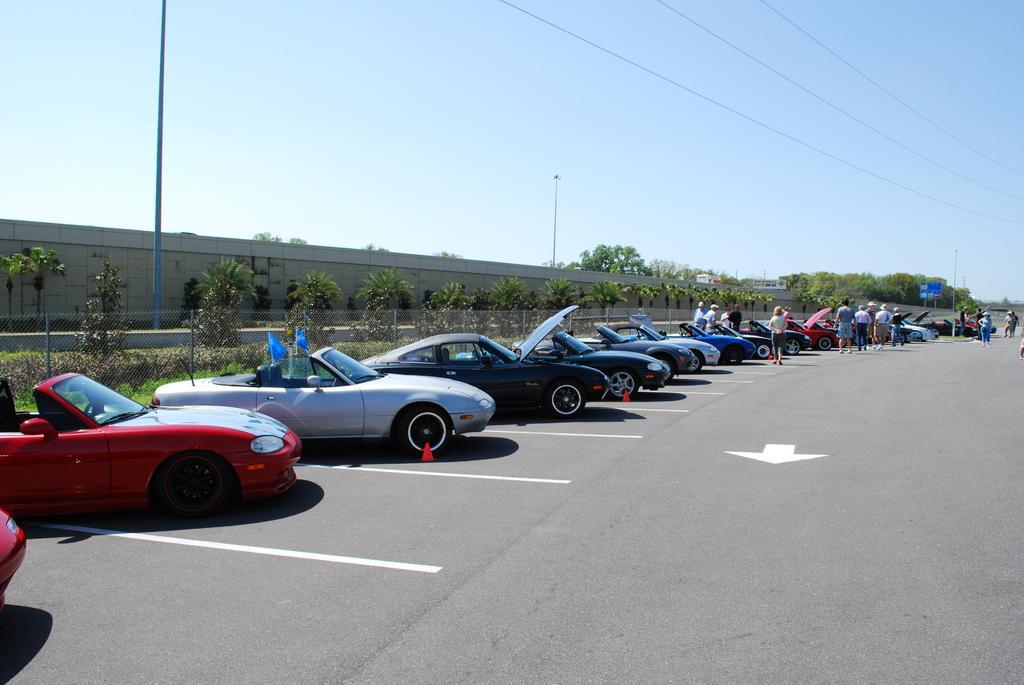How would you summarize this image in a sentence or two? In this image we can see few cars parked on the road, there are few people standing near the car, there is a fence, few plants, trees near the wall, a board, poles, wires and the sky on the top. 